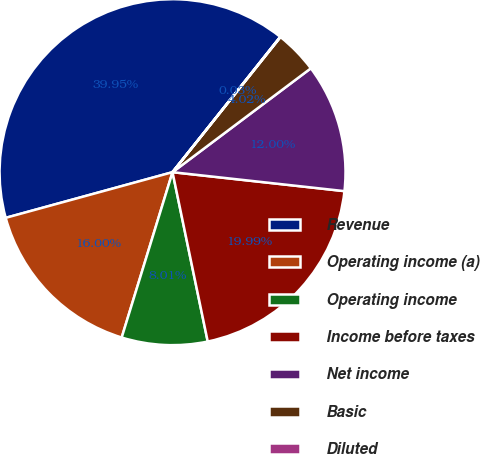<chart> <loc_0><loc_0><loc_500><loc_500><pie_chart><fcel>Revenue<fcel>Operating income (a)<fcel>Operating income<fcel>Income before taxes<fcel>Net income<fcel>Basic<fcel>Diluted<nl><fcel>39.95%<fcel>16.0%<fcel>8.01%<fcel>19.99%<fcel>12.0%<fcel>4.02%<fcel>0.03%<nl></chart> 